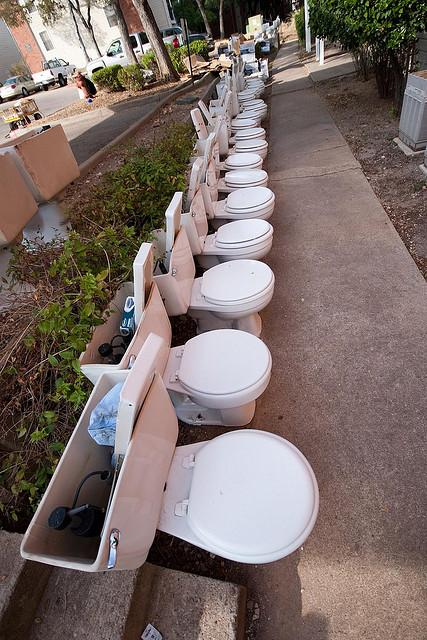What's happening with these toilets? repairs 